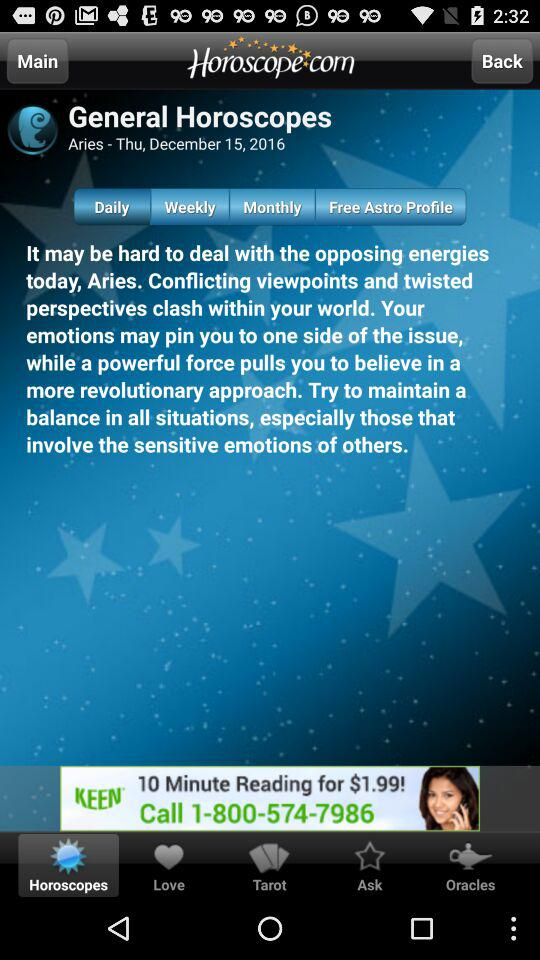What tab is selected? The selected tab is "Daily". 